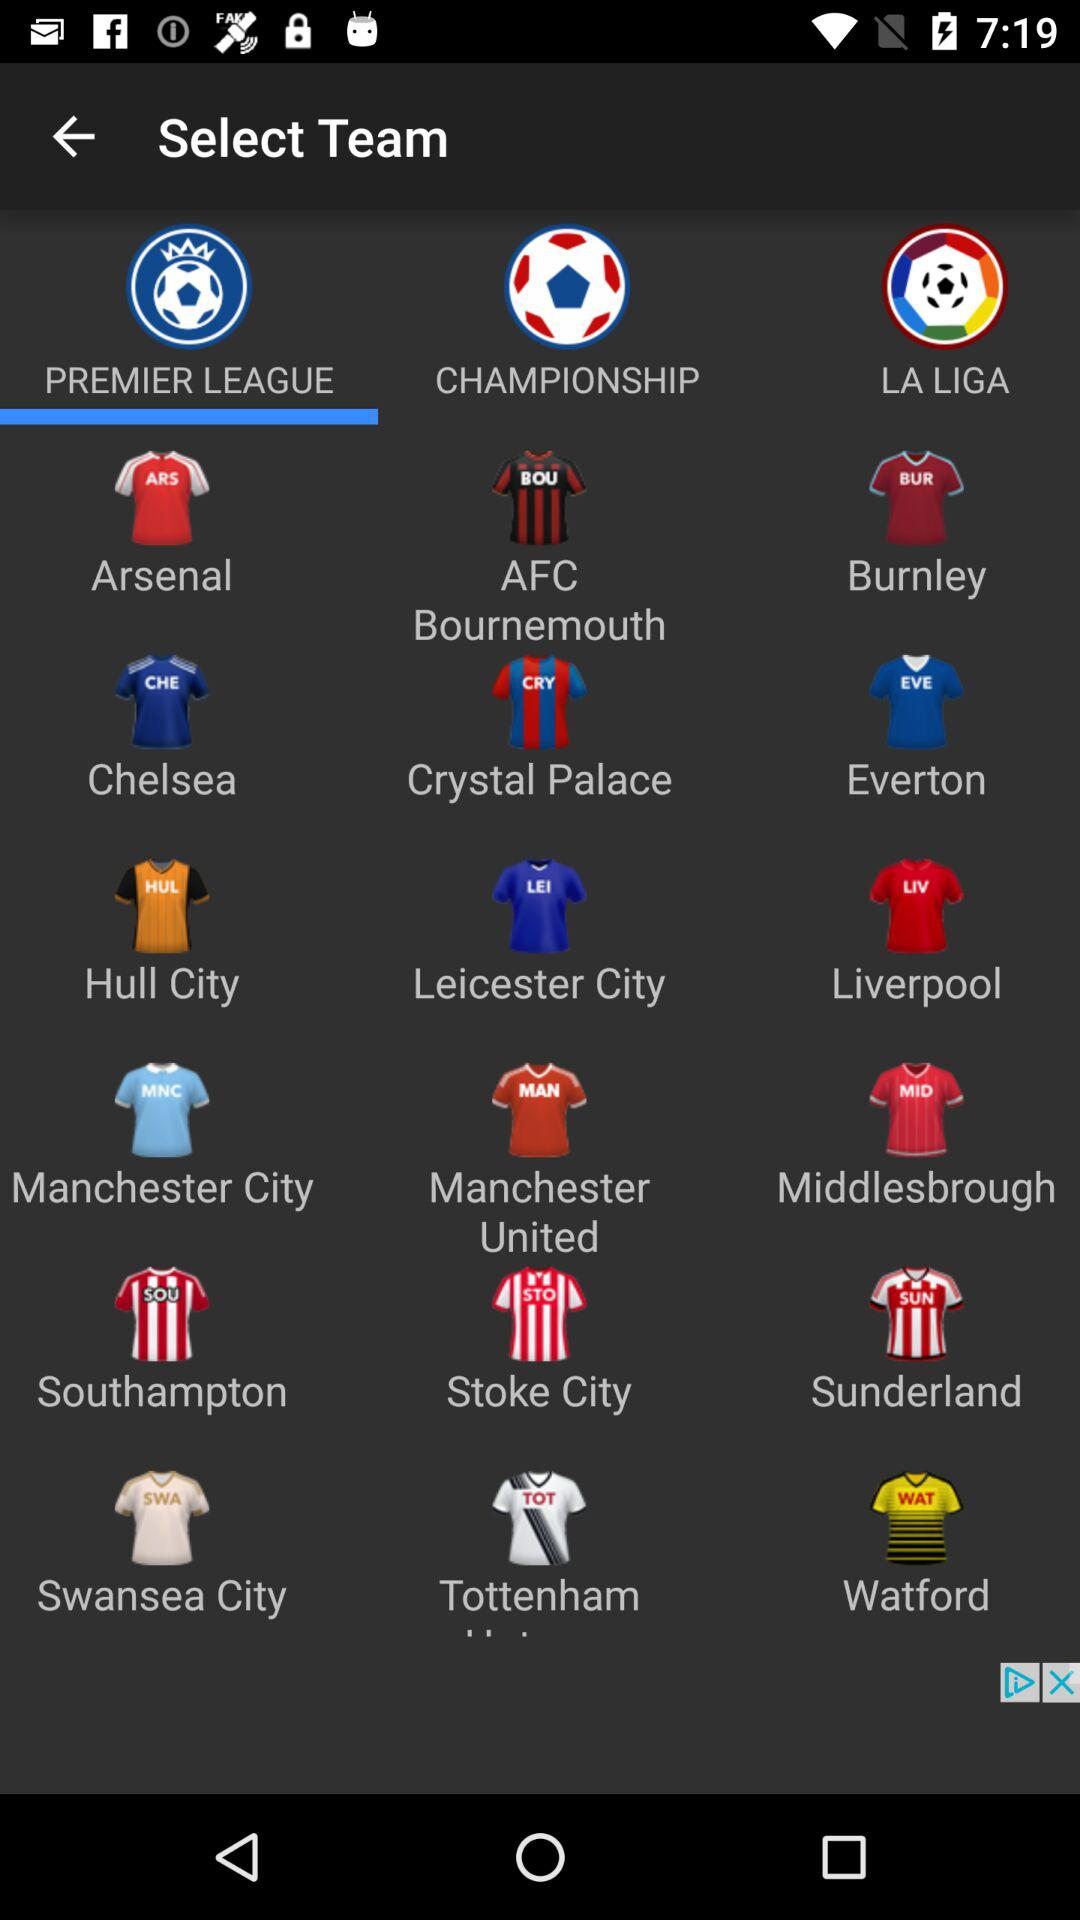Which tab am I on? You are on the "PREMIER LEAGUE" tab. 